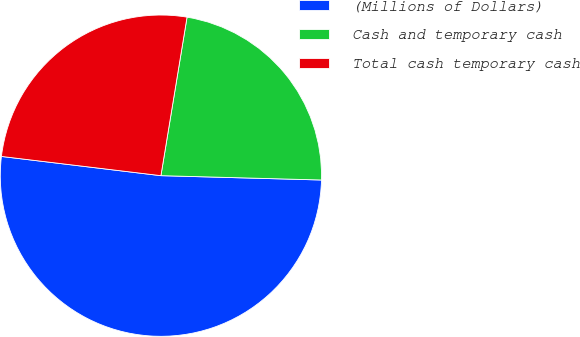Convert chart. <chart><loc_0><loc_0><loc_500><loc_500><pie_chart><fcel>(Millions of Dollars)<fcel>Cash and temporary cash<fcel>Total cash temporary cash<nl><fcel>51.48%<fcel>22.83%<fcel>25.69%<nl></chart> 